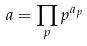Convert formula to latex. <formula><loc_0><loc_0><loc_500><loc_500>a = \prod _ { p } p ^ { a _ { p } }</formula> 